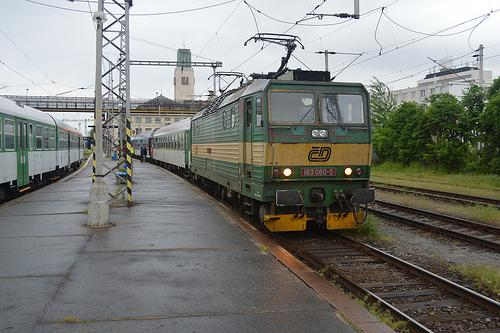Question: where was the picture taken?
Choices:
A. An airport.
B. A bus station.
C. A train station.
D. A parking lot.
Answer with the letter. Answer: C Question: what weather event happened recently?
Choices:
A. Snow.
B. Rain.
C. Hail.
D. Thunderstorm.
Answer with the letter. Answer: B Question: how many trains are there?
Choices:
A. Three.
B. Four.
C. Five.
D. Two.
Answer with the letter. Answer: D Question: what are hanging above the trains?
Choices:
A. Signs.
B. Street lights.
C. Wires.
D. Traffic lights.
Answer with the letter. Answer: C Question: what type of power do the trains run on?
Choices:
A. Steam.
B. Coal.
C. Electricity.
D. Solar power.
Answer with the letter. Answer: C Question: what color are the clouds?
Choices:
A. Red.
B. White.
C. Blue.
D. Gray.
Answer with the letter. Answer: D 